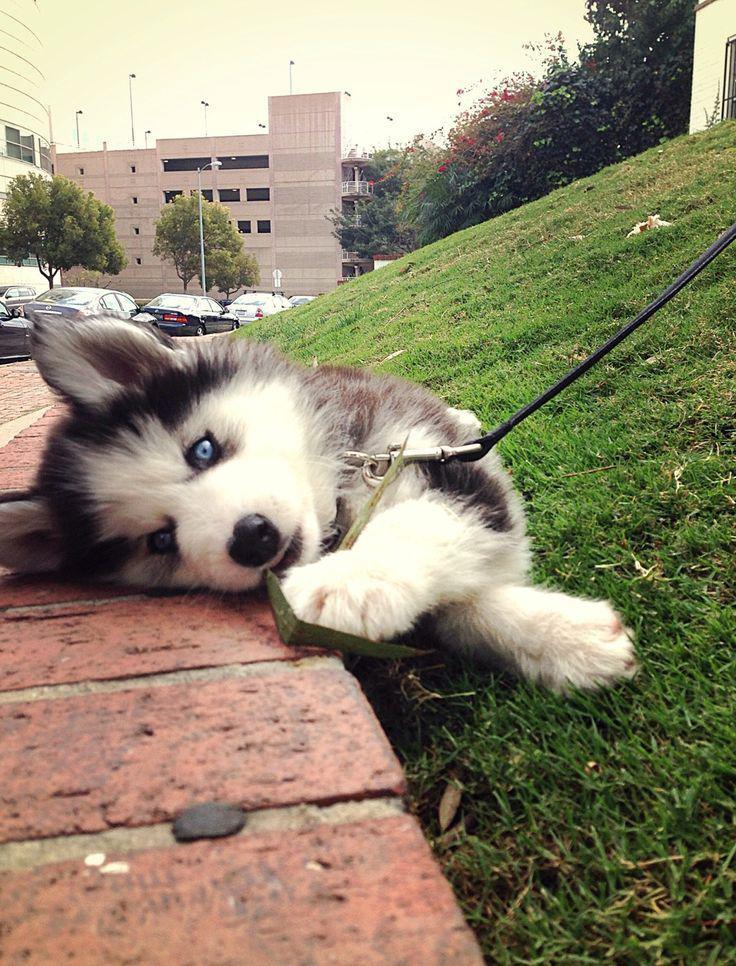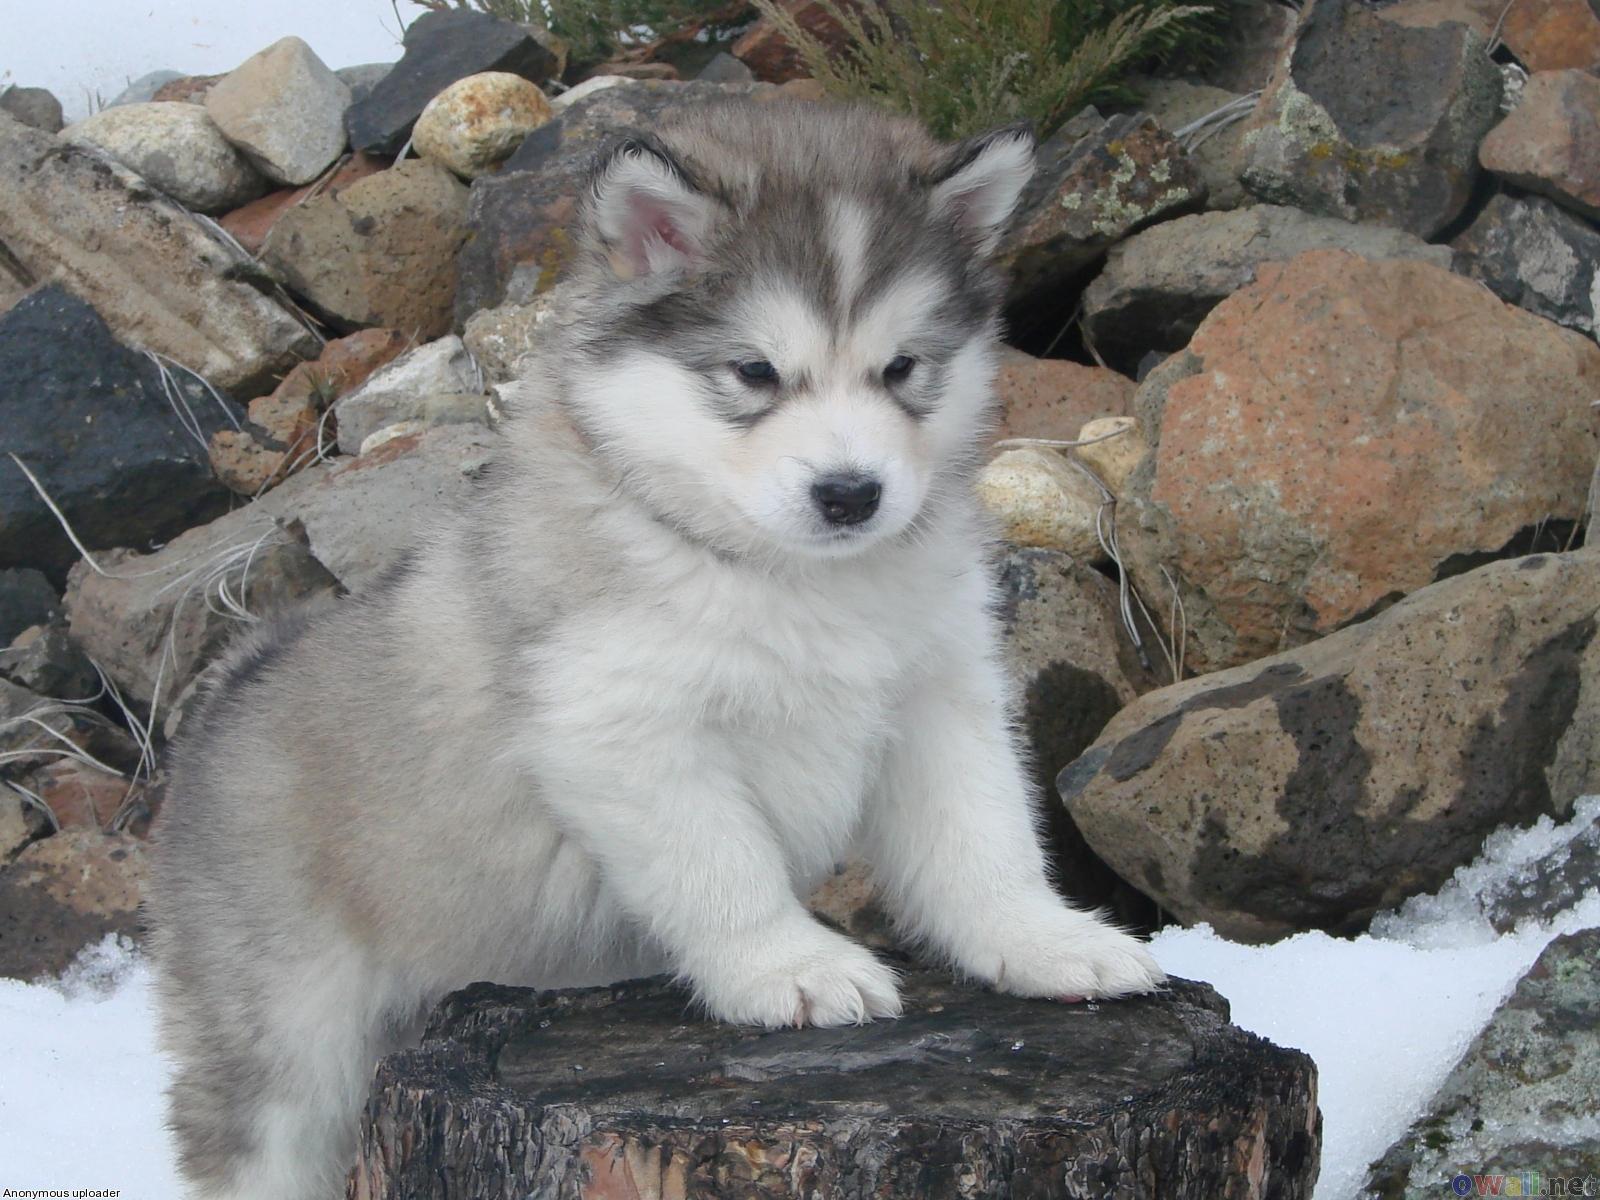The first image is the image on the left, the second image is the image on the right. Analyze the images presented: Is the assertion "There are exactly two dogs in total." valid? Answer yes or no. Yes. The first image is the image on the left, the second image is the image on the right. Evaluate the accuracy of this statement regarding the images: "A dog has its tongue out.". Is it true? Answer yes or no. No. 